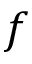Convert formula to latex. <formula><loc_0><loc_0><loc_500><loc_500>f</formula> 